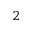Convert formula to latex. <formula><loc_0><loc_0><loc_500><loc_500>^ { 2 }</formula> 